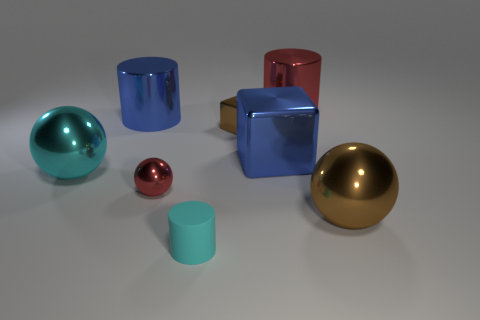Are there any other things that have the same material as the tiny cyan cylinder?
Provide a succinct answer. No. What number of balls are either small brown objects or big red objects?
Offer a very short reply. 0. How big is the object that is to the left of the big brown ball and in front of the small red object?
Your response must be concise. Small. What number of other objects are there of the same color as the small ball?
Provide a succinct answer. 1. Does the brown cube have the same material as the large sphere on the right side of the large cyan metallic sphere?
Your response must be concise. Yes. What number of objects are either tiny red shiny spheres left of the small brown shiny block or shiny objects?
Keep it short and to the point. 7. What is the shape of the small thing that is on the left side of the tiny brown shiny thing and behind the large brown metallic sphere?
Your answer should be compact. Sphere. There is a red ball that is the same material as the large blue cylinder; what is its size?
Offer a very short reply. Small. How many objects are tiny metallic objects behind the cyan shiny ball or small things that are in front of the blue metal block?
Your answer should be compact. 3. Does the brown object in front of the brown shiny cube have the same size as the large cyan ball?
Give a very brief answer. Yes. 